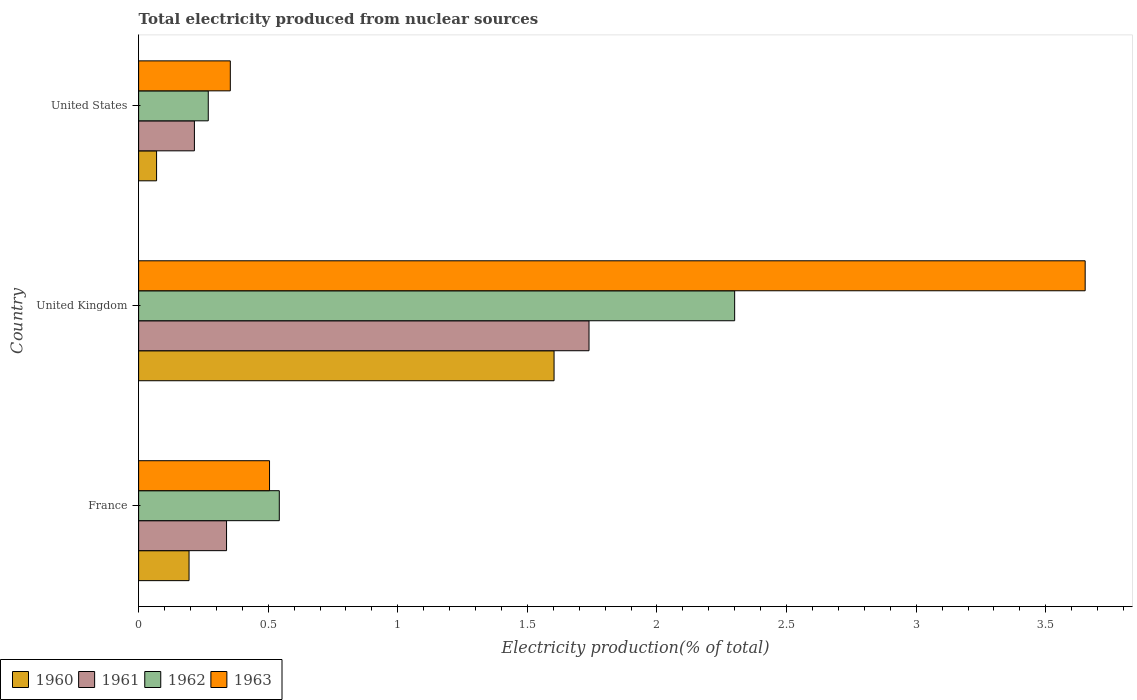How many groups of bars are there?
Ensure brevity in your answer.  3. Are the number of bars per tick equal to the number of legend labels?
Your response must be concise. Yes. In how many cases, is the number of bars for a given country not equal to the number of legend labels?
Your response must be concise. 0. What is the total electricity produced in 1961 in United Kingdom?
Your answer should be very brief. 1.74. Across all countries, what is the maximum total electricity produced in 1963?
Your answer should be compact. 3.65. Across all countries, what is the minimum total electricity produced in 1961?
Your response must be concise. 0.22. In which country was the total electricity produced in 1961 minimum?
Provide a short and direct response. United States. What is the total total electricity produced in 1960 in the graph?
Ensure brevity in your answer.  1.87. What is the difference between the total electricity produced in 1963 in United Kingdom and that in United States?
Ensure brevity in your answer.  3.3. What is the difference between the total electricity produced in 1961 in United States and the total electricity produced in 1962 in United Kingdom?
Your answer should be very brief. -2.08. What is the average total electricity produced in 1961 per country?
Ensure brevity in your answer.  0.76. What is the difference between the total electricity produced in 1963 and total electricity produced in 1961 in France?
Provide a succinct answer. 0.17. What is the ratio of the total electricity produced in 1960 in France to that in United Kingdom?
Your answer should be compact. 0.12. What is the difference between the highest and the second highest total electricity produced in 1960?
Provide a short and direct response. 1.41. What is the difference between the highest and the lowest total electricity produced in 1963?
Provide a short and direct response. 3.3. In how many countries, is the total electricity produced in 1961 greater than the average total electricity produced in 1961 taken over all countries?
Provide a short and direct response. 1. Is the sum of the total electricity produced in 1961 in France and United Kingdom greater than the maximum total electricity produced in 1962 across all countries?
Provide a short and direct response. No. What does the 2nd bar from the top in United States represents?
Keep it short and to the point. 1962. Is it the case that in every country, the sum of the total electricity produced in 1961 and total electricity produced in 1960 is greater than the total electricity produced in 1963?
Ensure brevity in your answer.  No. How many bars are there?
Give a very brief answer. 12. Are all the bars in the graph horizontal?
Provide a succinct answer. Yes. How many countries are there in the graph?
Provide a short and direct response. 3. What is the difference between two consecutive major ticks on the X-axis?
Your answer should be very brief. 0.5. Where does the legend appear in the graph?
Your answer should be compact. Bottom left. How many legend labels are there?
Provide a short and direct response. 4. How are the legend labels stacked?
Your answer should be compact. Horizontal. What is the title of the graph?
Offer a very short reply. Total electricity produced from nuclear sources. What is the Electricity production(% of total) in 1960 in France?
Provide a succinct answer. 0.19. What is the Electricity production(% of total) of 1961 in France?
Give a very brief answer. 0.34. What is the Electricity production(% of total) in 1962 in France?
Your response must be concise. 0.54. What is the Electricity production(% of total) of 1963 in France?
Your answer should be very brief. 0.51. What is the Electricity production(% of total) of 1960 in United Kingdom?
Your response must be concise. 1.6. What is the Electricity production(% of total) in 1961 in United Kingdom?
Provide a succinct answer. 1.74. What is the Electricity production(% of total) in 1962 in United Kingdom?
Keep it short and to the point. 2.3. What is the Electricity production(% of total) of 1963 in United Kingdom?
Offer a very short reply. 3.65. What is the Electricity production(% of total) in 1960 in United States?
Ensure brevity in your answer.  0.07. What is the Electricity production(% of total) of 1961 in United States?
Keep it short and to the point. 0.22. What is the Electricity production(% of total) in 1962 in United States?
Your answer should be compact. 0.27. What is the Electricity production(% of total) of 1963 in United States?
Keep it short and to the point. 0.35. Across all countries, what is the maximum Electricity production(% of total) of 1960?
Offer a very short reply. 1.6. Across all countries, what is the maximum Electricity production(% of total) of 1961?
Give a very brief answer. 1.74. Across all countries, what is the maximum Electricity production(% of total) in 1962?
Ensure brevity in your answer.  2.3. Across all countries, what is the maximum Electricity production(% of total) of 1963?
Your answer should be very brief. 3.65. Across all countries, what is the minimum Electricity production(% of total) in 1960?
Provide a short and direct response. 0.07. Across all countries, what is the minimum Electricity production(% of total) of 1961?
Give a very brief answer. 0.22. Across all countries, what is the minimum Electricity production(% of total) of 1962?
Provide a short and direct response. 0.27. Across all countries, what is the minimum Electricity production(% of total) of 1963?
Offer a terse response. 0.35. What is the total Electricity production(% of total) in 1960 in the graph?
Your answer should be very brief. 1.87. What is the total Electricity production(% of total) of 1961 in the graph?
Your response must be concise. 2.29. What is the total Electricity production(% of total) of 1962 in the graph?
Your answer should be compact. 3.11. What is the total Electricity production(% of total) of 1963 in the graph?
Your answer should be very brief. 4.51. What is the difference between the Electricity production(% of total) in 1960 in France and that in United Kingdom?
Ensure brevity in your answer.  -1.41. What is the difference between the Electricity production(% of total) of 1961 in France and that in United Kingdom?
Ensure brevity in your answer.  -1.4. What is the difference between the Electricity production(% of total) in 1962 in France and that in United Kingdom?
Make the answer very short. -1.76. What is the difference between the Electricity production(% of total) in 1963 in France and that in United Kingdom?
Make the answer very short. -3.15. What is the difference between the Electricity production(% of total) in 1960 in France and that in United States?
Ensure brevity in your answer.  0.13. What is the difference between the Electricity production(% of total) of 1961 in France and that in United States?
Your response must be concise. 0.12. What is the difference between the Electricity production(% of total) in 1962 in France and that in United States?
Offer a terse response. 0.27. What is the difference between the Electricity production(% of total) in 1963 in France and that in United States?
Ensure brevity in your answer.  0.15. What is the difference between the Electricity production(% of total) of 1960 in United Kingdom and that in United States?
Your answer should be compact. 1.53. What is the difference between the Electricity production(% of total) of 1961 in United Kingdom and that in United States?
Keep it short and to the point. 1.52. What is the difference between the Electricity production(% of total) in 1962 in United Kingdom and that in United States?
Make the answer very short. 2.03. What is the difference between the Electricity production(% of total) in 1963 in United Kingdom and that in United States?
Your response must be concise. 3.3. What is the difference between the Electricity production(% of total) in 1960 in France and the Electricity production(% of total) in 1961 in United Kingdom?
Make the answer very short. -1.54. What is the difference between the Electricity production(% of total) of 1960 in France and the Electricity production(% of total) of 1962 in United Kingdom?
Your answer should be compact. -2.11. What is the difference between the Electricity production(% of total) in 1960 in France and the Electricity production(% of total) in 1963 in United Kingdom?
Your answer should be compact. -3.46. What is the difference between the Electricity production(% of total) of 1961 in France and the Electricity production(% of total) of 1962 in United Kingdom?
Make the answer very short. -1.96. What is the difference between the Electricity production(% of total) in 1961 in France and the Electricity production(% of total) in 1963 in United Kingdom?
Give a very brief answer. -3.31. What is the difference between the Electricity production(% of total) of 1962 in France and the Electricity production(% of total) of 1963 in United Kingdom?
Ensure brevity in your answer.  -3.11. What is the difference between the Electricity production(% of total) of 1960 in France and the Electricity production(% of total) of 1961 in United States?
Offer a terse response. -0.02. What is the difference between the Electricity production(% of total) in 1960 in France and the Electricity production(% of total) in 1962 in United States?
Offer a very short reply. -0.07. What is the difference between the Electricity production(% of total) of 1960 in France and the Electricity production(% of total) of 1963 in United States?
Provide a short and direct response. -0.16. What is the difference between the Electricity production(% of total) of 1961 in France and the Electricity production(% of total) of 1962 in United States?
Your answer should be very brief. 0.07. What is the difference between the Electricity production(% of total) of 1961 in France and the Electricity production(% of total) of 1963 in United States?
Make the answer very short. -0.01. What is the difference between the Electricity production(% of total) of 1962 in France and the Electricity production(% of total) of 1963 in United States?
Ensure brevity in your answer.  0.19. What is the difference between the Electricity production(% of total) in 1960 in United Kingdom and the Electricity production(% of total) in 1961 in United States?
Your response must be concise. 1.39. What is the difference between the Electricity production(% of total) in 1960 in United Kingdom and the Electricity production(% of total) in 1962 in United States?
Offer a very short reply. 1.33. What is the difference between the Electricity production(% of total) of 1960 in United Kingdom and the Electricity production(% of total) of 1963 in United States?
Make the answer very short. 1.25. What is the difference between the Electricity production(% of total) in 1961 in United Kingdom and the Electricity production(% of total) in 1962 in United States?
Provide a succinct answer. 1.47. What is the difference between the Electricity production(% of total) of 1961 in United Kingdom and the Electricity production(% of total) of 1963 in United States?
Your response must be concise. 1.38. What is the difference between the Electricity production(% of total) in 1962 in United Kingdom and the Electricity production(% of total) in 1963 in United States?
Keep it short and to the point. 1.95. What is the average Electricity production(% of total) of 1960 per country?
Make the answer very short. 0.62. What is the average Electricity production(% of total) of 1961 per country?
Keep it short and to the point. 0.76. What is the average Electricity production(% of total) of 1963 per country?
Ensure brevity in your answer.  1.5. What is the difference between the Electricity production(% of total) in 1960 and Electricity production(% of total) in 1961 in France?
Your response must be concise. -0.14. What is the difference between the Electricity production(% of total) of 1960 and Electricity production(% of total) of 1962 in France?
Your answer should be compact. -0.35. What is the difference between the Electricity production(% of total) of 1960 and Electricity production(% of total) of 1963 in France?
Provide a succinct answer. -0.31. What is the difference between the Electricity production(% of total) in 1961 and Electricity production(% of total) in 1962 in France?
Offer a very short reply. -0.2. What is the difference between the Electricity production(% of total) of 1961 and Electricity production(% of total) of 1963 in France?
Make the answer very short. -0.17. What is the difference between the Electricity production(% of total) in 1962 and Electricity production(% of total) in 1963 in France?
Offer a very short reply. 0.04. What is the difference between the Electricity production(% of total) of 1960 and Electricity production(% of total) of 1961 in United Kingdom?
Keep it short and to the point. -0.13. What is the difference between the Electricity production(% of total) in 1960 and Electricity production(% of total) in 1962 in United Kingdom?
Your answer should be compact. -0.7. What is the difference between the Electricity production(% of total) of 1960 and Electricity production(% of total) of 1963 in United Kingdom?
Provide a succinct answer. -2.05. What is the difference between the Electricity production(% of total) of 1961 and Electricity production(% of total) of 1962 in United Kingdom?
Offer a terse response. -0.56. What is the difference between the Electricity production(% of total) in 1961 and Electricity production(% of total) in 1963 in United Kingdom?
Provide a succinct answer. -1.91. What is the difference between the Electricity production(% of total) of 1962 and Electricity production(% of total) of 1963 in United Kingdom?
Make the answer very short. -1.35. What is the difference between the Electricity production(% of total) of 1960 and Electricity production(% of total) of 1961 in United States?
Provide a succinct answer. -0.15. What is the difference between the Electricity production(% of total) in 1960 and Electricity production(% of total) in 1962 in United States?
Ensure brevity in your answer.  -0.2. What is the difference between the Electricity production(% of total) of 1960 and Electricity production(% of total) of 1963 in United States?
Make the answer very short. -0.28. What is the difference between the Electricity production(% of total) of 1961 and Electricity production(% of total) of 1962 in United States?
Make the answer very short. -0.05. What is the difference between the Electricity production(% of total) in 1961 and Electricity production(% of total) in 1963 in United States?
Ensure brevity in your answer.  -0.14. What is the difference between the Electricity production(% of total) of 1962 and Electricity production(% of total) of 1963 in United States?
Offer a very short reply. -0.09. What is the ratio of the Electricity production(% of total) of 1960 in France to that in United Kingdom?
Make the answer very short. 0.12. What is the ratio of the Electricity production(% of total) of 1961 in France to that in United Kingdom?
Your answer should be very brief. 0.2. What is the ratio of the Electricity production(% of total) of 1962 in France to that in United Kingdom?
Offer a very short reply. 0.24. What is the ratio of the Electricity production(% of total) in 1963 in France to that in United Kingdom?
Your answer should be compact. 0.14. What is the ratio of the Electricity production(% of total) of 1960 in France to that in United States?
Ensure brevity in your answer.  2.81. What is the ratio of the Electricity production(% of total) in 1961 in France to that in United States?
Provide a short and direct response. 1.58. What is the ratio of the Electricity production(% of total) of 1962 in France to that in United States?
Your answer should be compact. 2.02. What is the ratio of the Electricity production(% of total) of 1963 in France to that in United States?
Make the answer very short. 1.43. What is the ratio of the Electricity production(% of total) in 1960 in United Kingdom to that in United States?
Your answer should be compact. 23.14. What is the ratio of the Electricity production(% of total) in 1961 in United Kingdom to that in United States?
Provide a short and direct response. 8.08. What is the ratio of the Electricity production(% of total) in 1962 in United Kingdom to that in United States?
Ensure brevity in your answer.  8.56. What is the ratio of the Electricity production(% of total) in 1963 in United Kingdom to that in United States?
Ensure brevity in your answer.  10.32. What is the difference between the highest and the second highest Electricity production(% of total) of 1960?
Offer a terse response. 1.41. What is the difference between the highest and the second highest Electricity production(% of total) in 1961?
Offer a very short reply. 1.4. What is the difference between the highest and the second highest Electricity production(% of total) in 1962?
Make the answer very short. 1.76. What is the difference between the highest and the second highest Electricity production(% of total) of 1963?
Your answer should be compact. 3.15. What is the difference between the highest and the lowest Electricity production(% of total) in 1960?
Your answer should be compact. 1.53. What is the difference between the highest and the lowest Electricity production(% of total) of 1961?
Keep it short and to the point. 1.52. What is the difference between the highest and the lowest Electricity production(% of total) in 1962?
Make the answer very short. 2.03. What is the difference between the highest and the lowest Electricity production(% of total) of 1963?
Provide a succinct answer. 3.3. 